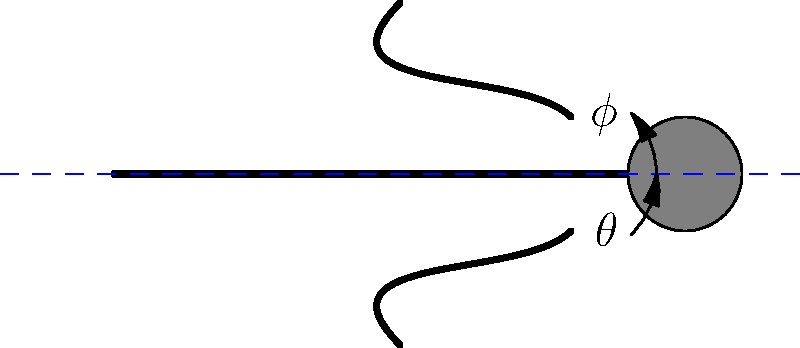In competitive swimming, the angle between a swimmer's body and the water surface is crucial for stroke efficiency. Based on the diagram, if the angle between the swimmer's body and the water surface is $\theta$, and the angle between the swimmer's arms and their body is $\phi$, what is the optimal relationship between these angles for maximum propulsion? To understand the optimal relationship between angles $\theta$ and $\phi$ for maximum propulsion, we need to consider the principles of fluid dynamics and biomechanics in swimming:

1. Body position: The angle $\theta$ represents the body's alignment with the water surface. A smaller $\theta$ generally reduces drag, allowing for a more streamlined position.

2. Arm position: The angle $\phi$ represents the position of the arms relative to the body during the power phase of the stroke.

3. Propulsive force: Maximum propulsion is achieved when the swimmer's arms push directly backwards against the water.

4. Optimal angle relationship: For the arms to push directly backwards when the body is at an angle $\theta$ to the water surface, the arm angle $\phi$ should complement $\theta$.

5. Complementary angles: The optimal relationship is when $\theta + \phi = 90°$. This ensures that the arms are perpendicular to the water surface during the power phase, maximizing backward push and forward propulsion.

6. Adjustments: As $\theta$ changes during different phases of the stroke, $\phi$ should adjust accordingly to maintain this complementary relationship.

7. Trade-off: While a smaller $\theta$ reduces drag, it may limit the range of motion for the arms. Swimmers must find a balance that optimizes both streamlining and propulsive force.

Therefore, the optimal relationship between $\theta$ and $\phi$ for maximum propulsion is that they should be complementary angles, summing to 90°.
Answer: $\theta + \phi = 90°$ 